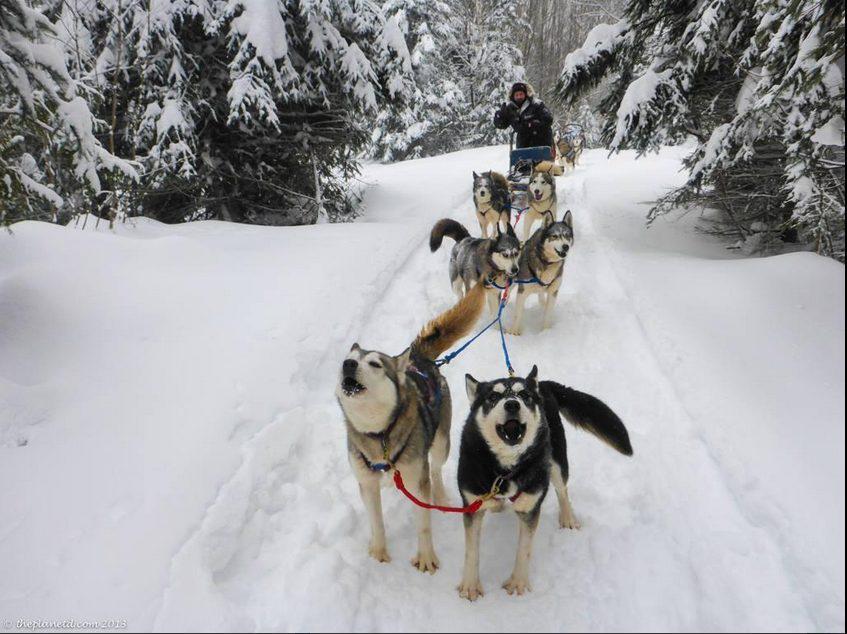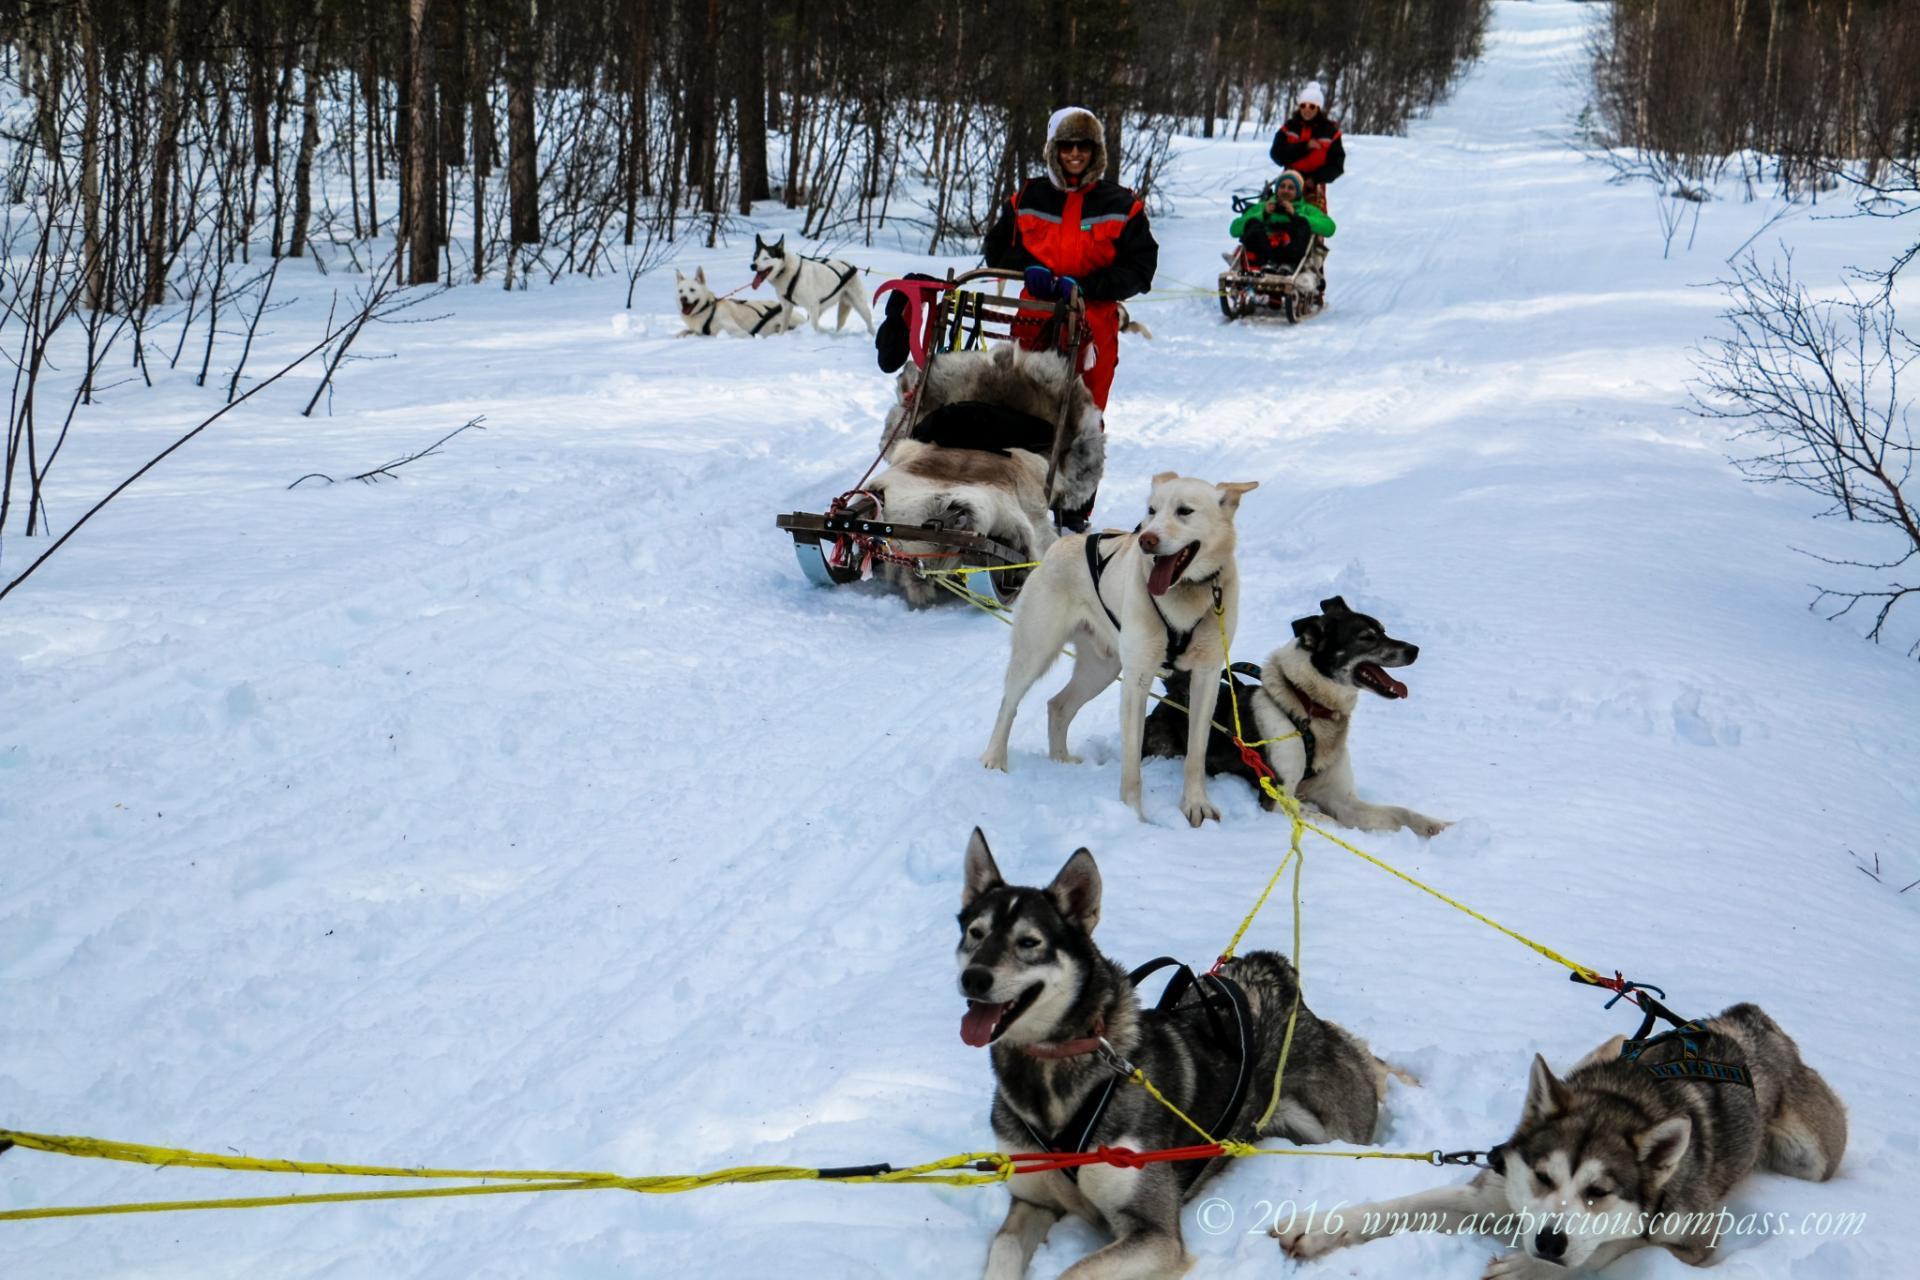The first image is the image on the left, the second image is the image on the right. Evaluate the accuracy of this statement regarding the images: "One image does not show a rider with a sled.". Is it true? Answer yes or no. No. The first image is the image on the left, the second image is the image on the right. Analyze the images presented: Is the assertion "There is a person wearing red outerwear." valid? Answer yes or no. Yes. 